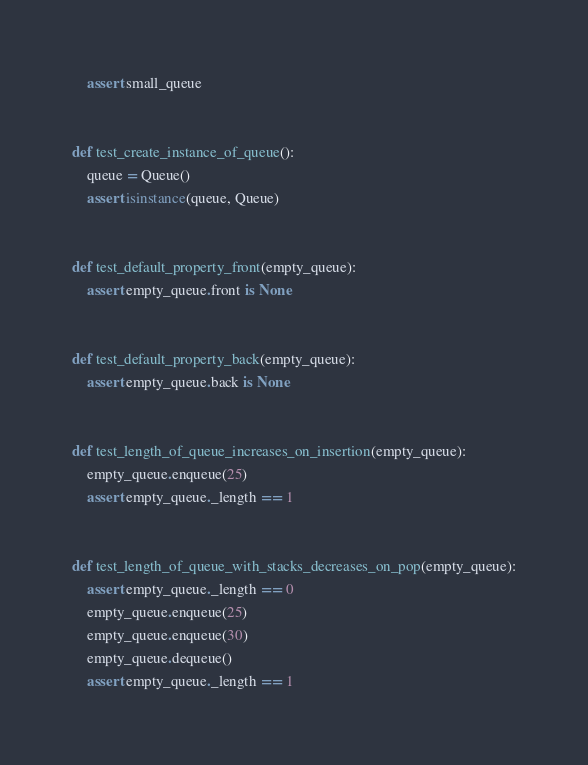<code> <loc_0><loc_0><loc_500><loc_500><_Python_>    assert small_queue


def test_create_instance_of_queue():
    queue = Queue()
    assert isinstance(queue, Queue)


def test_default_property_front(empty_queue):
    assert empty_queue.front is None


def test_default_property_back(empty_queue):
    assert empty_queue.back is None


def test_length_of_queue_increases_on_insertion(empty_queue):
    empty_queue.enqueue(25)
    assert empty_queue._length == 1


def test_length_of_queue_with_stacks_decreases_on_pop(empty_queue):
    assert empty_queue._length == 0
    empty_queue.enqueue(25)
    empty_queue.enqueue(30)
    empty_queue.dequeue()
    assert empty_queue._length == 1
</code> 